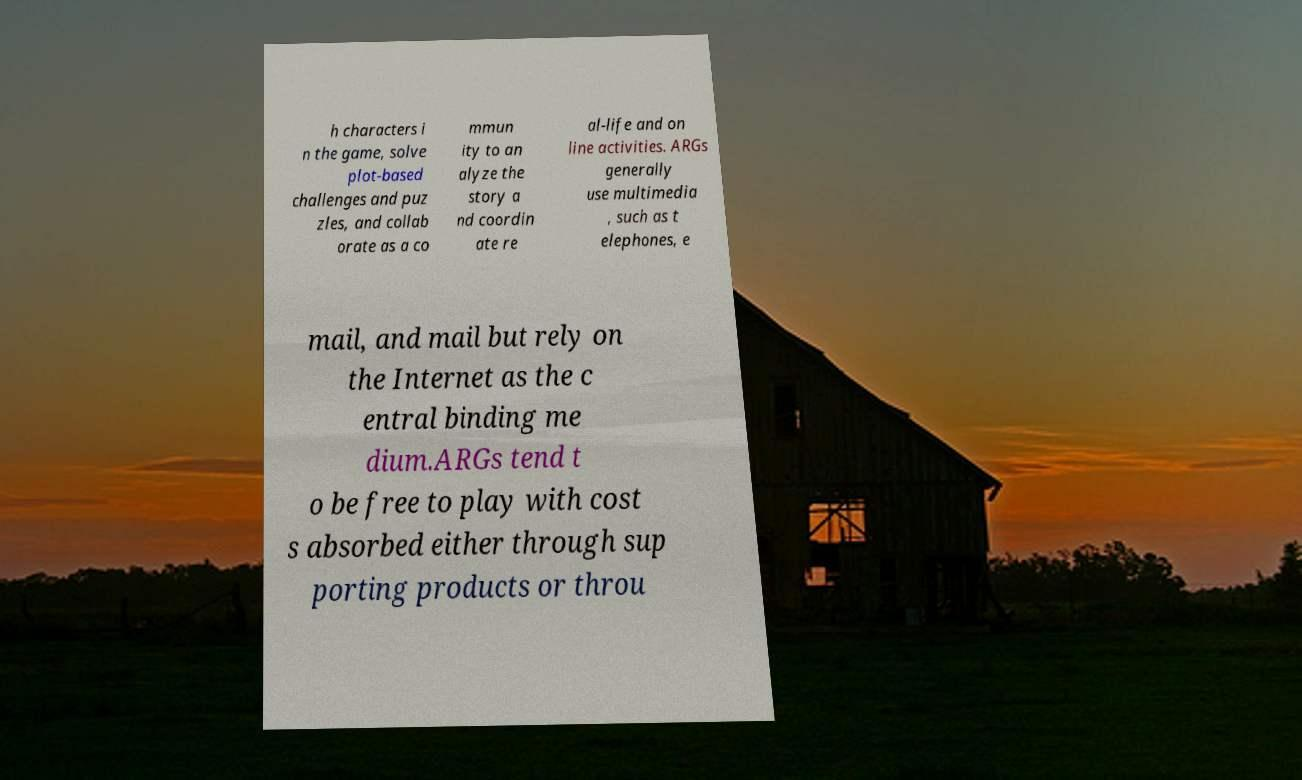Can you read and provide the text displayed in the image?This photo seems to have some interesting text. Can you extract and type it out for me? h characters i n the game, solve plot-based challenges and puz zles, and collab orate as a co mmun ity to an alyze the story a nd coordin ate re al-life and on line activities. ARGs generally use multimedia , such as t elephones, e mail, and mail but rely on the Internet as the c entral binding me dium.ARGs tend t o be free to play with cost s absorbed either through sup porting products or throu 